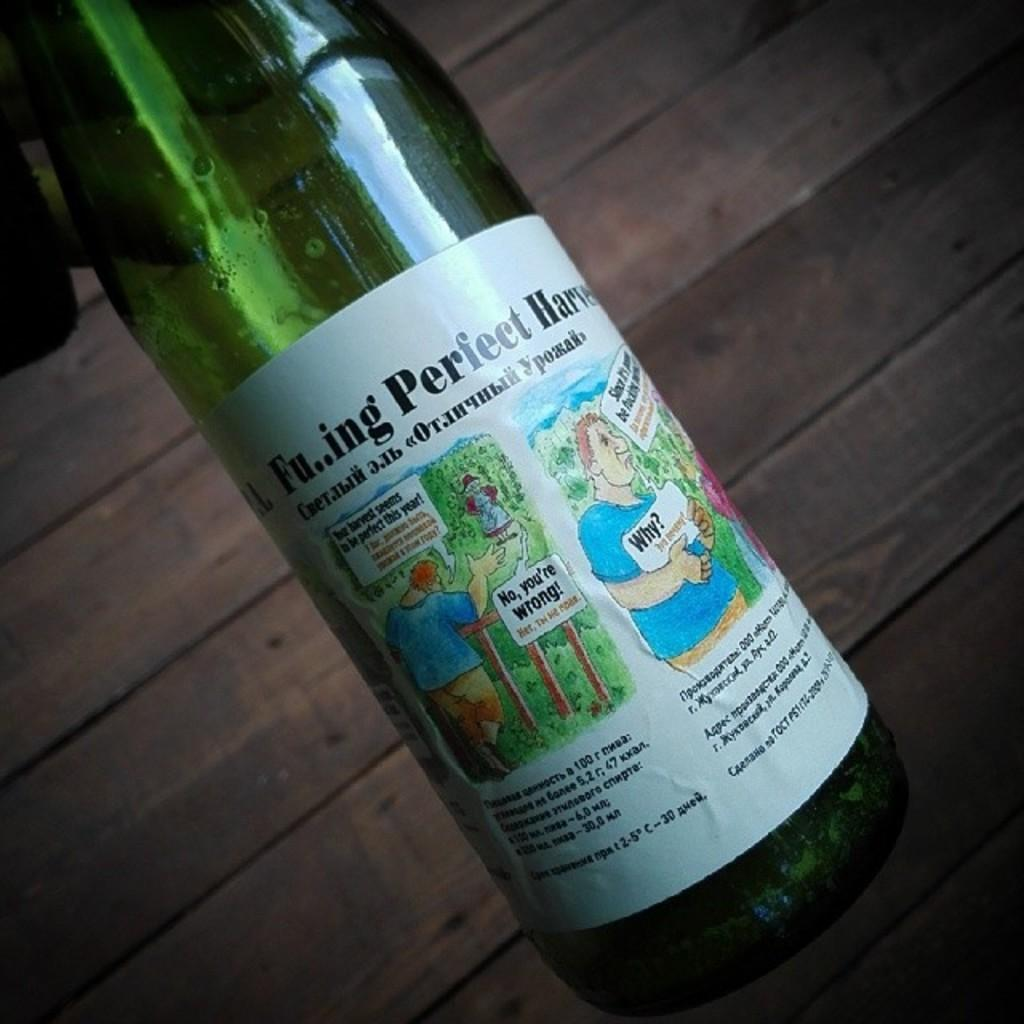<image>
Give a short and clear explanation of the subsequent image. A bottle with a cartoon style photo as a label has a heading that include fu..ing perfect. 